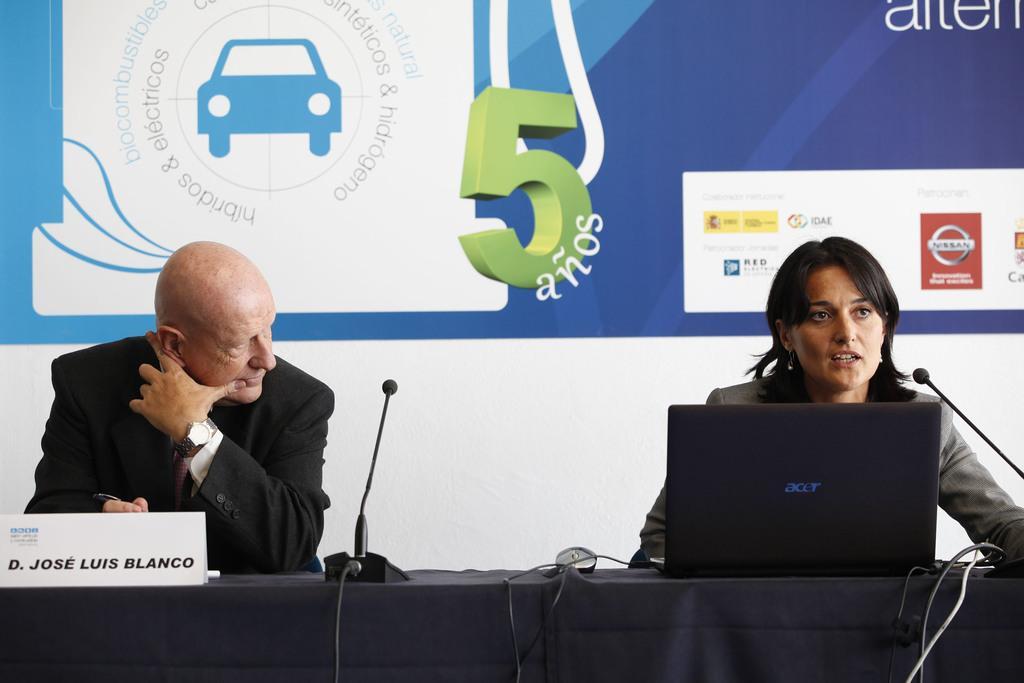In one or two sentences, can you explain what this image depicts? In this image, we can see a few people. We can see a table covered with a cloth and some objects like a laptop and a board with some text. We can also see some microphones. In the background, we can see the wall and a poster with some images and text. 